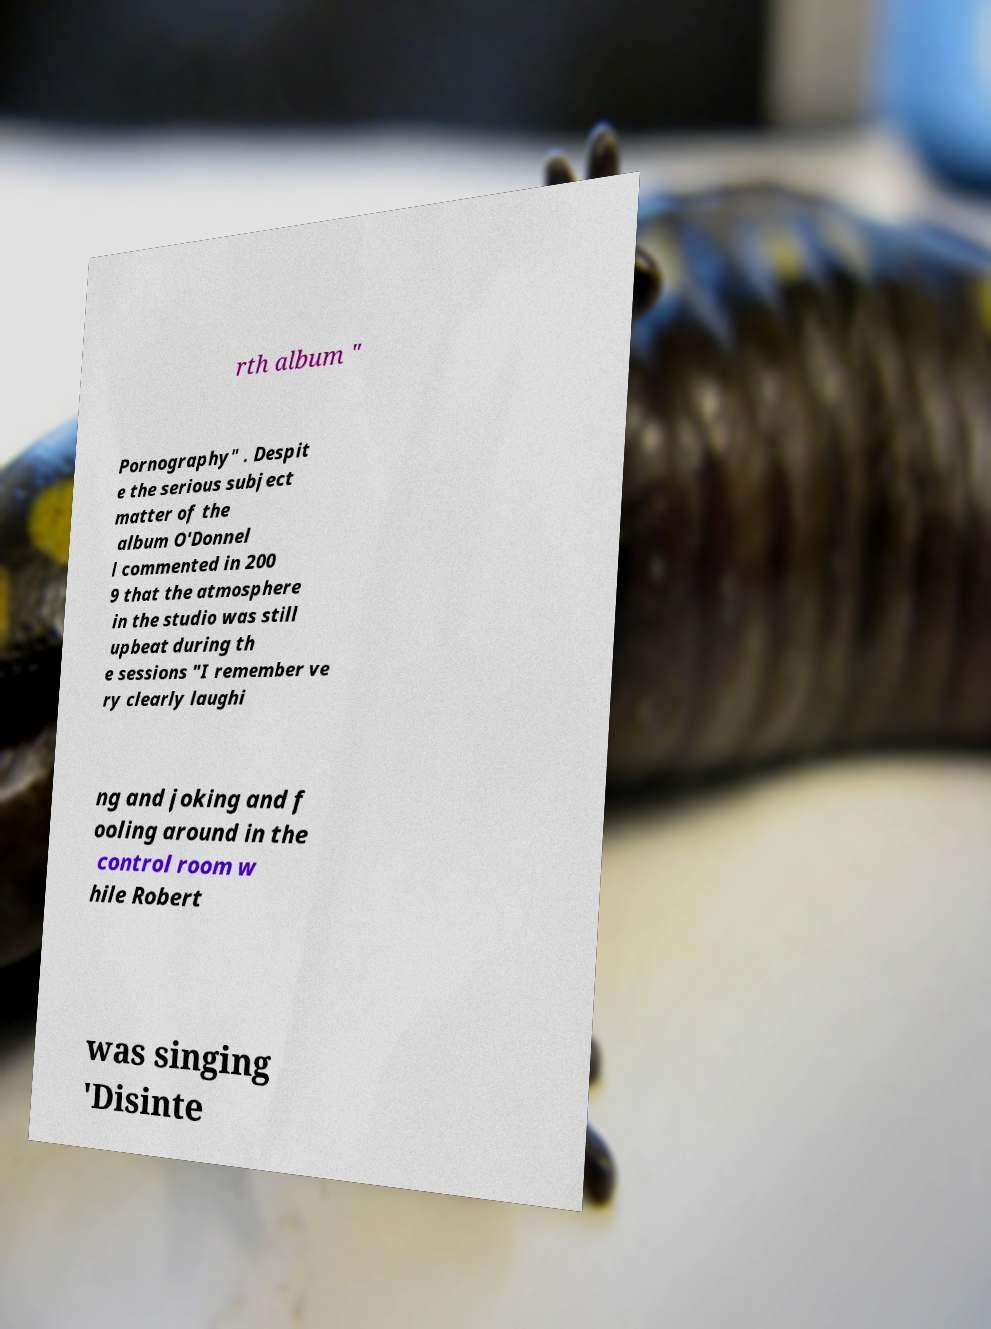For documentation purposes, I need the text within this image transcribed. Could you provide that? rth album " Pornography" . Despit e the serious subject matter of the album O'Donnel l commented in 200 9 that the atmosphere in the studio was still upbeat during th e sessions "I remember ve ry clearly laughi ng and joking and f ooling around in the control room w hile Robert was singing 'Disinte 